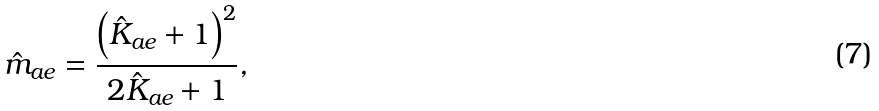<formula> <loc_0><loc_0><loc_500><loc_500>\hat { m } _ { a e } = \frac { \left ( \hat { K } _ { a e } + 1 \right ) ^ { 2 } } { 2 \hat { K } _ { a e } + 1 } ,</formula> 